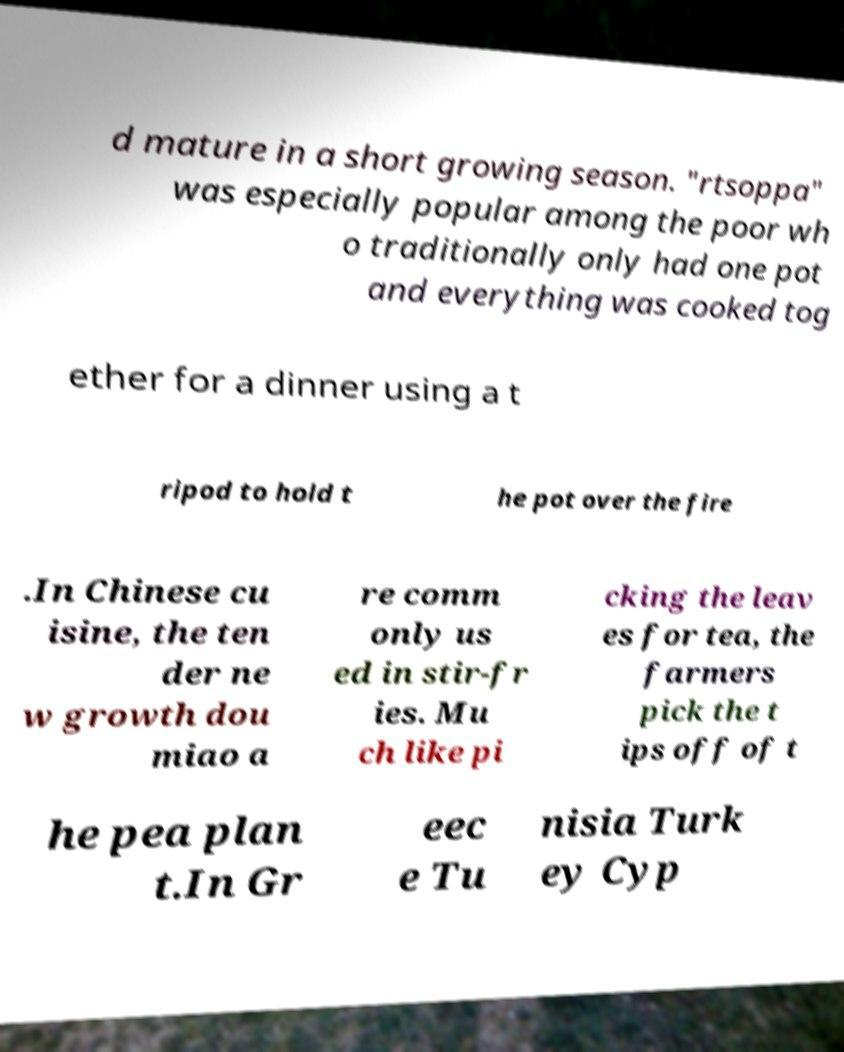Could you assist in decoding the text presented in this image and type it out clearly? d mature in a short growing season. "rtsoppa" was especially popular among the poor wh o traditionally only had one pot and everything was cooked tog ether for a dinner using a t ripod to hold t he pot over the fire .In Chinese cu isine, the ten der ne w growth dou miao a re comm only us ed in stir-fr ies. Mu ch like pi cking the leav es for tea, the farmers pick the t ips off of t he pea plan t.In Gr eec e Tu nisia Turk ey Cyp 